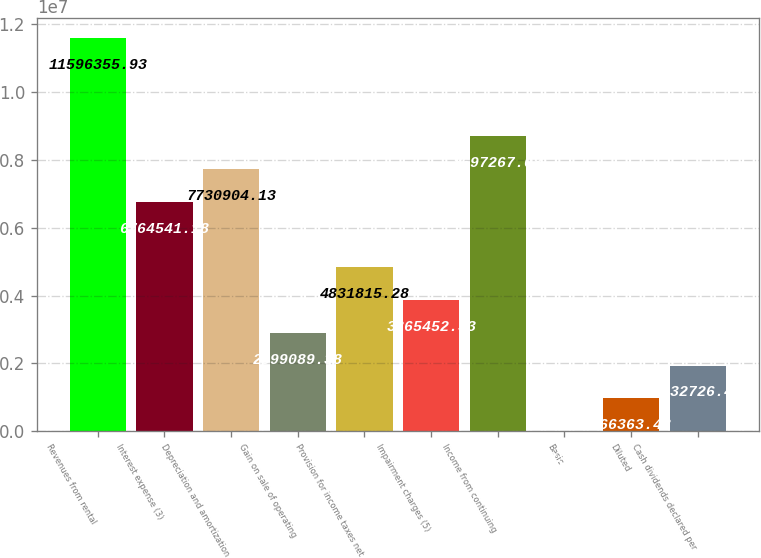<chart> <loc_0><loc_0><loc_500><loc_500><bar_chart><fcel>Revenues from rental<fcel>Interest expense (3)<fcel>Depreciation and amortization<fcel>Gain on sale of operating<fcel>Provision for income taxes net<fcel>Impairment charges (5)<fcel>Income from continuing<fcel>Basic<fcel>Diluted<fcel>Cash dividends declared per<nl><fcel>1.15964e+07<fcel>6.76454e+06<fcel>7.7309e+06<fcel>2.89909e+06<fcel>4.83182e+06<fcel>3.86545e+06<fcel>8.69727e+06<fcel>0.53<fcel>966363<fcel>1.93273e+06<nl></chart> 